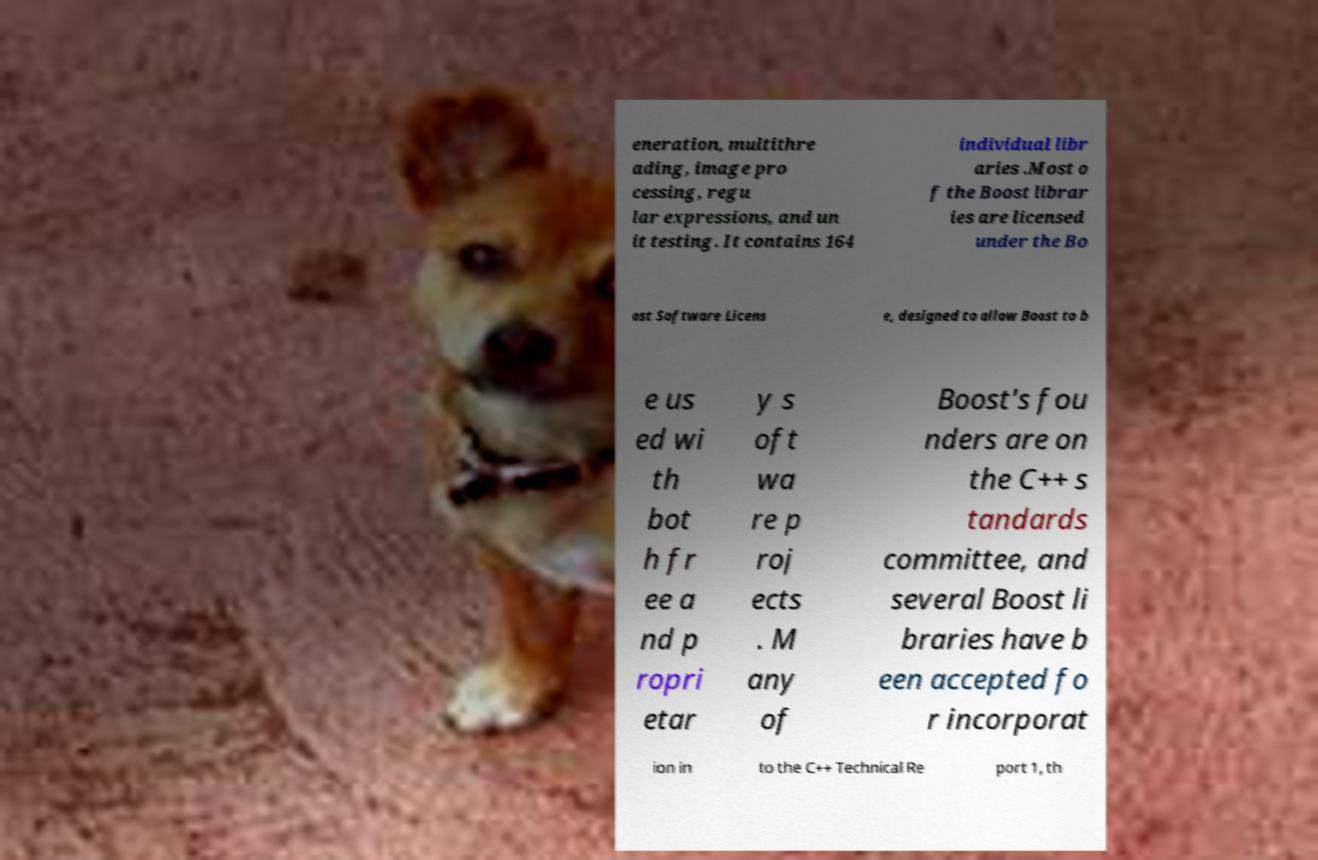There's text embedded in this image that I need extracted. Can you transcribe it verbatim? eneration, multithre ading, image pro cessing, regu lar expressions, and un it testing. It contains 164 individual libr aries .Most o f the Boost librar ies are licensed under the Bo ost Software Licens e, designed to allow Boost to b e us ed wi th bot h fr ee a nd p ropri etar y s oft wa re p roj ects . M any of Boost's fou nders are on the C++ s tandards committee, and several Boost li braries have b een accepted fo r incorporat ion in to the C++ Technical Re port 1, th 